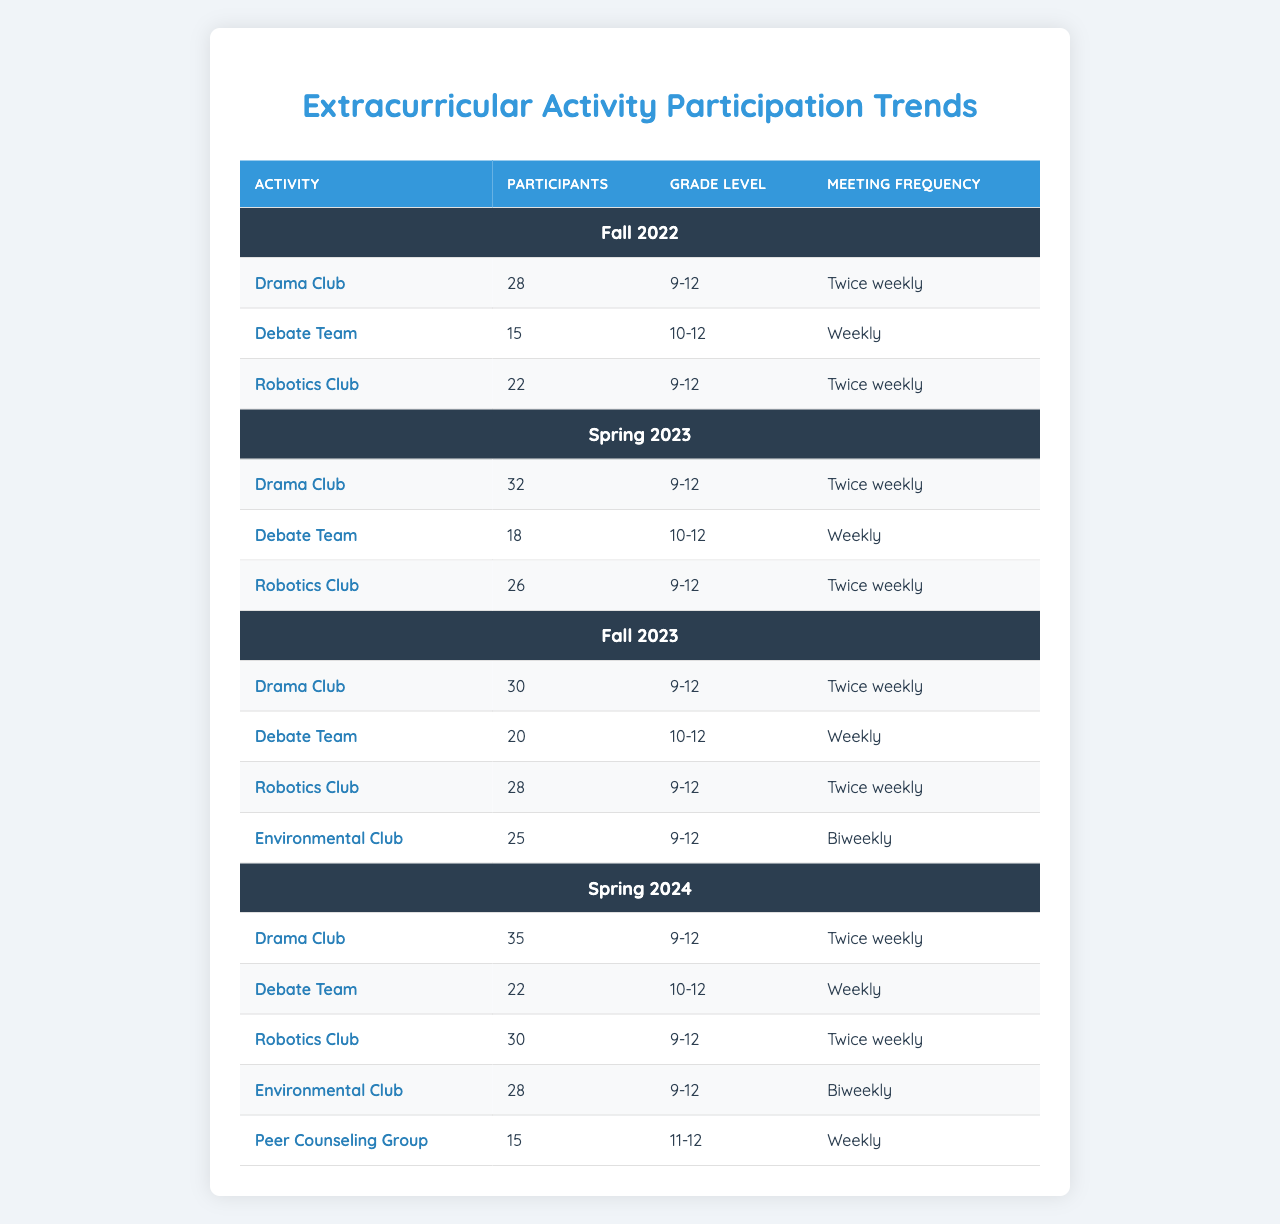What was the highest number of participants in the Drama Club across the semesters? The Drama Club had 35 participants in Spring 2024, which is the highest number recorded in the table.
Answer: 35 How many participants were there in total for the Debate Team across all semesters? The Debate Team had 15 (Fall 2022) + 18 (Spring 2023) + 20 (Fall 2023) + 22 (Spring 2024) = 75 participants total.
Answer: 75 Did the number of participants in the Robotics Club increase from Fall 2022 to Spring 2024? The Robotics Club had 22 participants in Fall 2022 and increased to 30 participants in Spring 2024, indicating growth.
Answer: Yes Which semester had the Environmental Club? The Environmental Club was present in Fall 2023 and Spring 2024.
Answer: Fall 2023 and Spring 2024 What was the meeting frequency for the Peer Counseling Group? The Peer Counseling Group met weekly, as specified in the data for Spring 2024.
Answer: Weekly Compare the number of participants in the Drama Club from Fall 2022 to Fall 2023. What was the difference? The Drama Club had 28 participants in Fall 2022 and 30 participants in Fall 2023. The difference is 30 - 28 = 2 participants.
Answer: 2 Which extracurricular activity consistently had grade levels from 9 to 12? The Drama Club and the Robotics Club consistently had participants from grades 9 to 12 in each semester of the table.
Answer: Drama Club and Robotics Club In how many semesters did the Environmental Club participate? The Environmental Club participated in 2 semesters: Fall 2023 and Spring 2024, as shown in the table.
Answer: 2 What is the average number of participants in the Debate Team across all semesters? The Debate Team had 15 + 18 + 20 + 22 = 75 participants across 4 semesters. The average is 75 / 4 = 18.75.
Answer: 18.75 Was there a semester when the Robotics Club had the lowest number of participants? If so, which semester was it? Yes, the Robotics Club had the lowest number of participants in Fall 2022, with 22 participants being the least across all semesters.
Answer: Fall 2022 How many more participants did the Robotics Club have in Spring 2024 compared to Spring 2023? The Robotics Club had 30 participants in Spring 2024 and 26 in Spring 2023. The difference is 30 - 26 = 4 participants more.
Answer: 4 